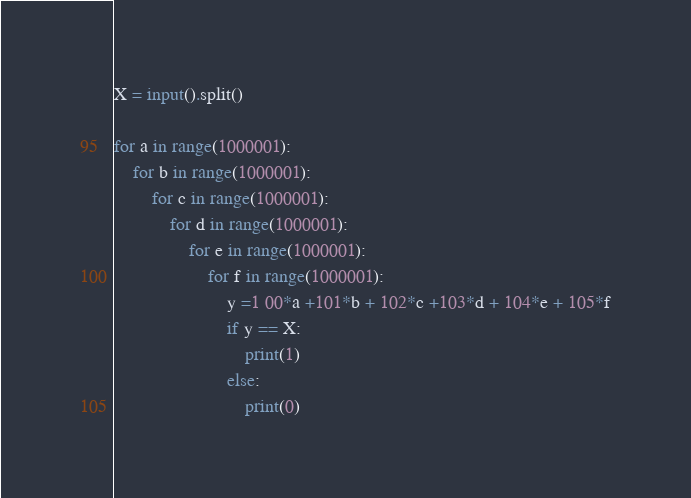Convert code to text. <code><loc_0><loc_0><loc_500><loc_500><_Python_>X = input().split()

for a in range(1000001):
    for b in range(1000001):
        for c in range(1000001):
            for d in range(1000001):
                for e in range(1000001):
                    for f in range(1000001):
                        y =1 00*a +101*b + 102*c +103*d + 104*e + 105*f
                        if y == X:
                            print(1)
                        else:
                            print(0)</code> 